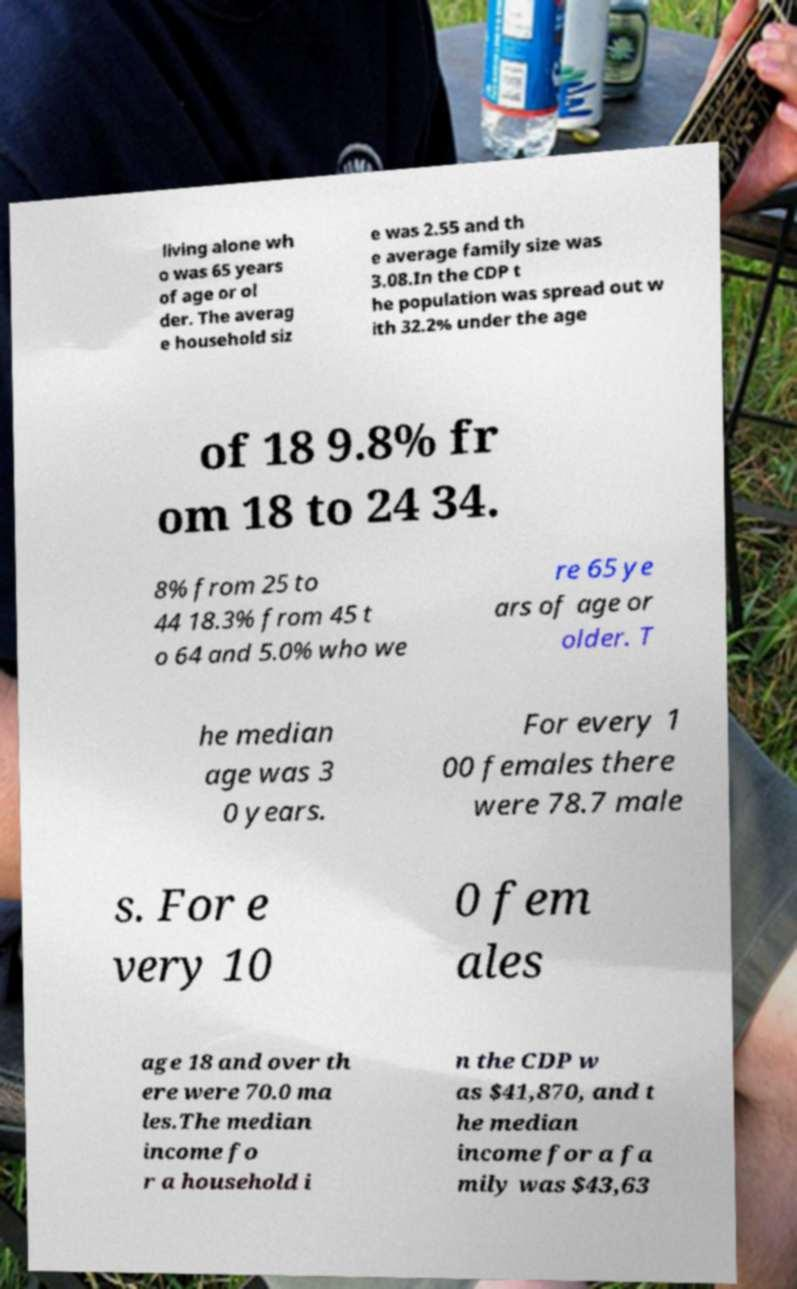Could you extract and type out the text from this image? living alone wh o was 65 years of age or ol der. The averag e household siz e was 2.55 and th e average family size was 3.08.In the CDP t he population was spread out w ith 32.2% under the age of 18 9.8% fr om 18 to 24 34. 8% from 25 to 44 18.3% from 45 t o 64 and 5.0% who we re 65 ye ars of age or older. T he median age was 3 0 years. For every 1 00 females there were 78.7 male s. For e very 10 0 fem ales age 18 and over th ere were 70.0 ma les.The median income fo r a household i n the CDP w as $41,870, and t he median income for a fa mily was $43,63 